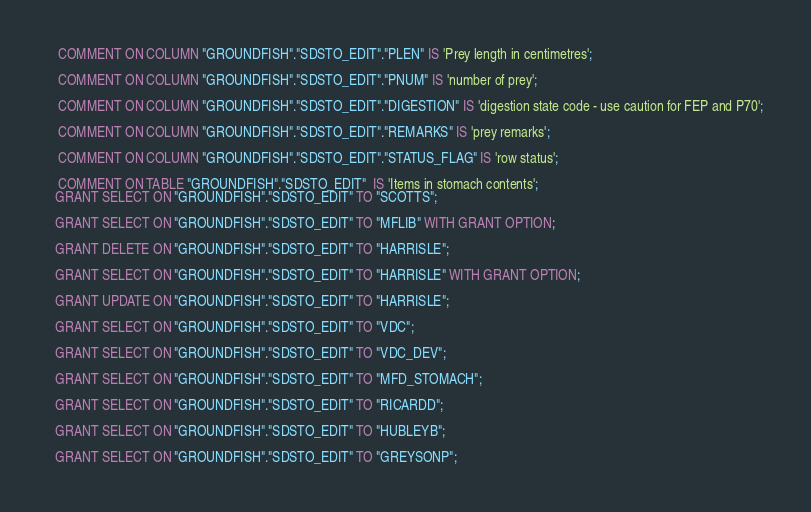<code> <loc_0><loc_0><loc_500><loc_500><_SQL_>   COMMENT ON COLUMN "GROUNDFISH"."SDSTO_EDIT"."PLEN" IS 'Prey length in centimetres';
 
   COMMENT ON COLUMN "GROUNDFISH"."SDSTO_EDIT"."PNUM" IS 'number of prey';
 
   COMMENT ON COLUMN "GROUNDFISH"."SDSTO_EDIT"."DIGESTION" IS 'digestion state code - use caution for FEP and P70';
 
   COMMENT ON COLUMN "GROUNDFISH"."SDSTO_EDIT"."REMARKS" IS 'prey remarks';
 
   COMMENT ON COLUMN "GROUNDFISH"."SDSTO_EDIT"."STATUS_FLAG" IS 'row status';
 
   COMMENT ON TABLE "GROUNDFISH"."SDSTO_EDIT"  IS 'Items in stomach contents';
  GRANT SELECT ON "GROUNDFISH"."SDSTO_EDIT" TO "SCOTTS";
 
  GRANT SELECT ON "GROUNDFISH"."SDSTO_EDIT" TO "MFLIB" WITH GRANT OPTION;
 
  GRANT DELETE ON "GROUNDFISH"."SDSTO_EDIT" TO "HARRISLE";
 
  GRANT SELECT ON "GROUNDFISH"."SDSTO_EDIT" TO "HARRISLE" WITH GRANT OPTION;
 
  GRANT UPDATE ON "GROUNDFISH"."SDSTO_EDIT" TO "HARRISLE";
 
  GRANT SELECT ON "GROUNDFISH"."SDSTO_EDIT" TO "VDC";
 
  GRANT SELECT ON "GROUNDFISH"."SDSTO_EDIT" TO "VDC_DEV";
 
  GRANT SELECT ON "GROUNDFISH"."SDSTO_EDIT" TO "MFD_STOMACH";
 
  GRANT SELECT ON "GROUNDFISH"."SDSTO_EDIT" TO "RICARDD";
 
  GRANT SELECT ON "GROUNDFISH"."SDSTO_EDIT" TO "HUBLEYB";
 
  GRANT SELECT ON "GROUNDFISH"."SDSTO_EDIT" TO "GREYSONP";
</code> 